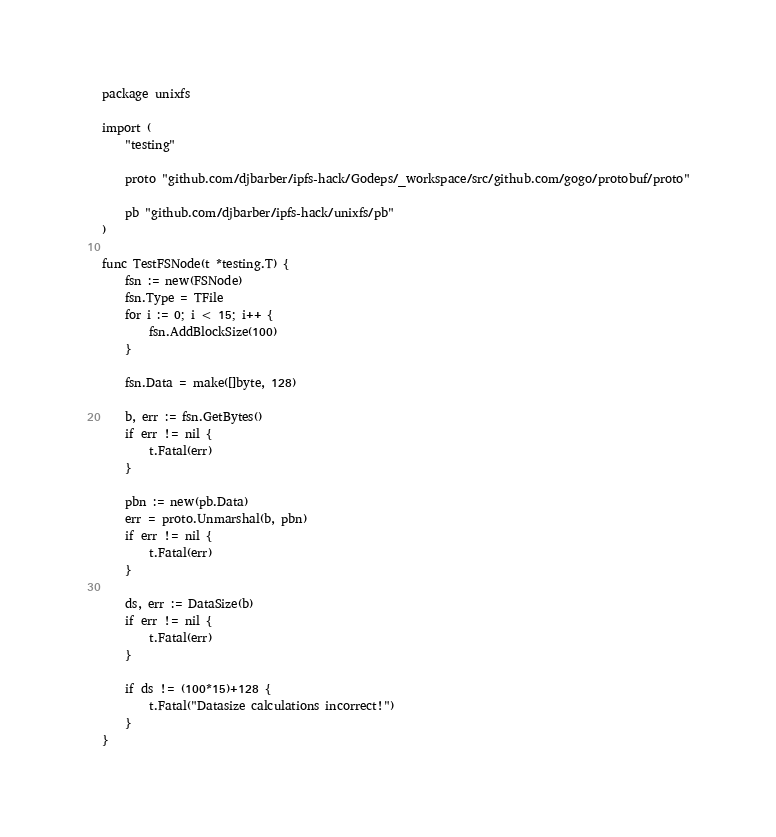<code> <loc_0><loc_0><loc_500><loc_500><_Go_>package unixfs

import (
	"testing"

	proto "github.com/djbarber/ipfs-hack/Godeps/_workspace/src/github.com/gogo/protobuf/proto"

	pb "github.com/djbarber/ipfs-hack/unixfs/pb"
)

func TestFSNode(t *testing.T) {
	fsn := new(FSNode)
	fsn.Type = TFile
	for i := 0; i < 15; i++ {
		fsn.AddBlockSize(100)
	}

	fsn.Data = make([]byte, 128)

	b, err := fsn.GetBytes()
	if err != nil {
		t.Fatal(err)
	}

	pbn := new(pb.Data)
	err = proto.Unmarshal(b, pbn)
	if err != nil {
		t.Fatal(err)
	}

	ds, err := DataSize(b)
	if err != nil {
		t.Fatal(err)
	}

	if ds != (100*15)+128 {
		t.Fatal("Datasize calculations incorrect!")
	}
}
</code> 